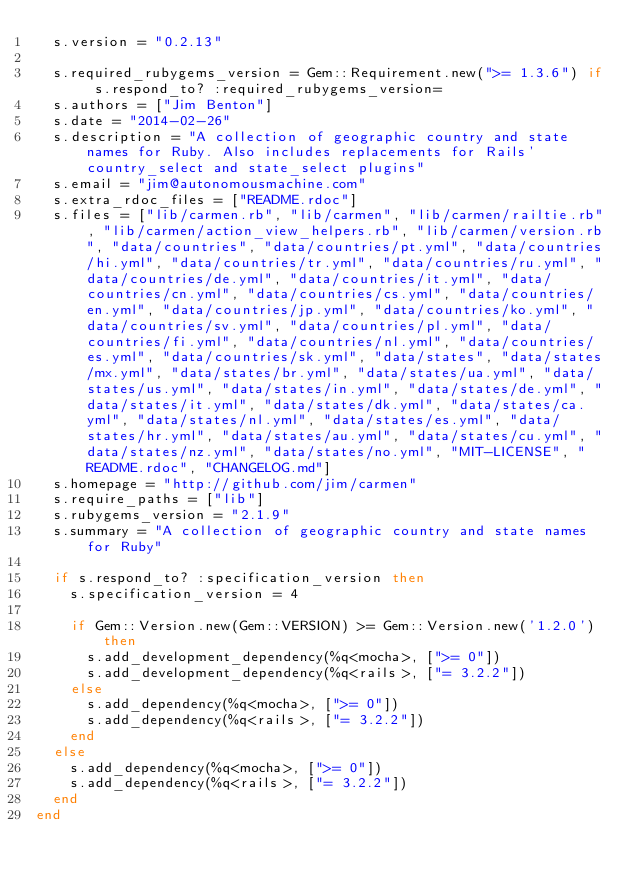<code> <loc_0><loc_0><loc_500><loc_500><_Ruby_>  s.version = "0.2.13"

  s.required_rubygems_version = Gem::Requirement.new(">= 1.3.6") if s.respond_to? :required_rubygems_version=
  s.authors = ["Jim Benton"]
  s.date = "2014-02-26"
  s.description = "A collection of geographic country and state names for Ruby. Also includes replacements for Rails' country_select and state_select plugins"
  s.email = "jim@autonomousmachine.com"
  s.extra_rdoc_files = ["README.rdoc"]
  s.files = ["lib/carmen.rb", "lib/carmen", "lib/carmen/railtie.rb", "lib/carmen/action_view_helpers.rb", "lib/carmen/version.rb", "data/countries", "data/countries/pt.yml", "data/countries/hi.yml", "data/countries/tr.yml", "data/countries/ru.yml", "data/countries/de.yml", "data/countries/it.yml", "data/countries/cn.yml", "data/countries/cs.yml", "data/countries/en.yml", "data/countries/jp.yml", "data/countries/ko.yml", "data/countries/sv.yml", "data/countries/pl.yml", "data/countries/fi.yml", "data/countries/nl.yml", "data/countries/es.yml", "data/countries/sk.yml", "data/states", "data/states/mx.yml", "data/states/br.yml", "data/states/ua.yml", "data/states/us.yml", "data/states/in.yml", "data/states/de.yml", "data/states/it.yml", "data/states/dk.yml", "data/states/ca.yml", "data/states/nl.yml", "data/states/es.yml", "data/states/hr.yml", "data/states/au.yml", "data/states/cu.yml", "data/states/nz.yml", "data/states/no.yml", "MIT-LICENSE", "README.rdoc", "CHANGELOG.md"]
  s.homepage = "http://github.com/jim/carmen"
  s.require_paths = ["lib"]
  s.rubygems_version = "2.1.9"
  s.summary = "A collection of geographic country and state names for Ruby"

  if s.respond_to? :specification_version then
    s.specification_version = 4

    if Gem::Version.new(Gem::VERSION) >= Gem::Version.new('1.2.0') then
      s.add_development_dependency(%q<mocha>, [">= 0"])
      s.add_development_dependency(%q<rails>, ["= 3.2.2"])
    else
      s.add_dependency(%q<mocha>, [">= 0"])
      s.add_dependency(%q<rails>, ["= 3.2.2"])
    end
  else
    s.add_dependency(%q<mocha>, [">= 0"])
    s.add_dependency(%q<rails>, ["= 3.2.2"])
  end
end
</code> 